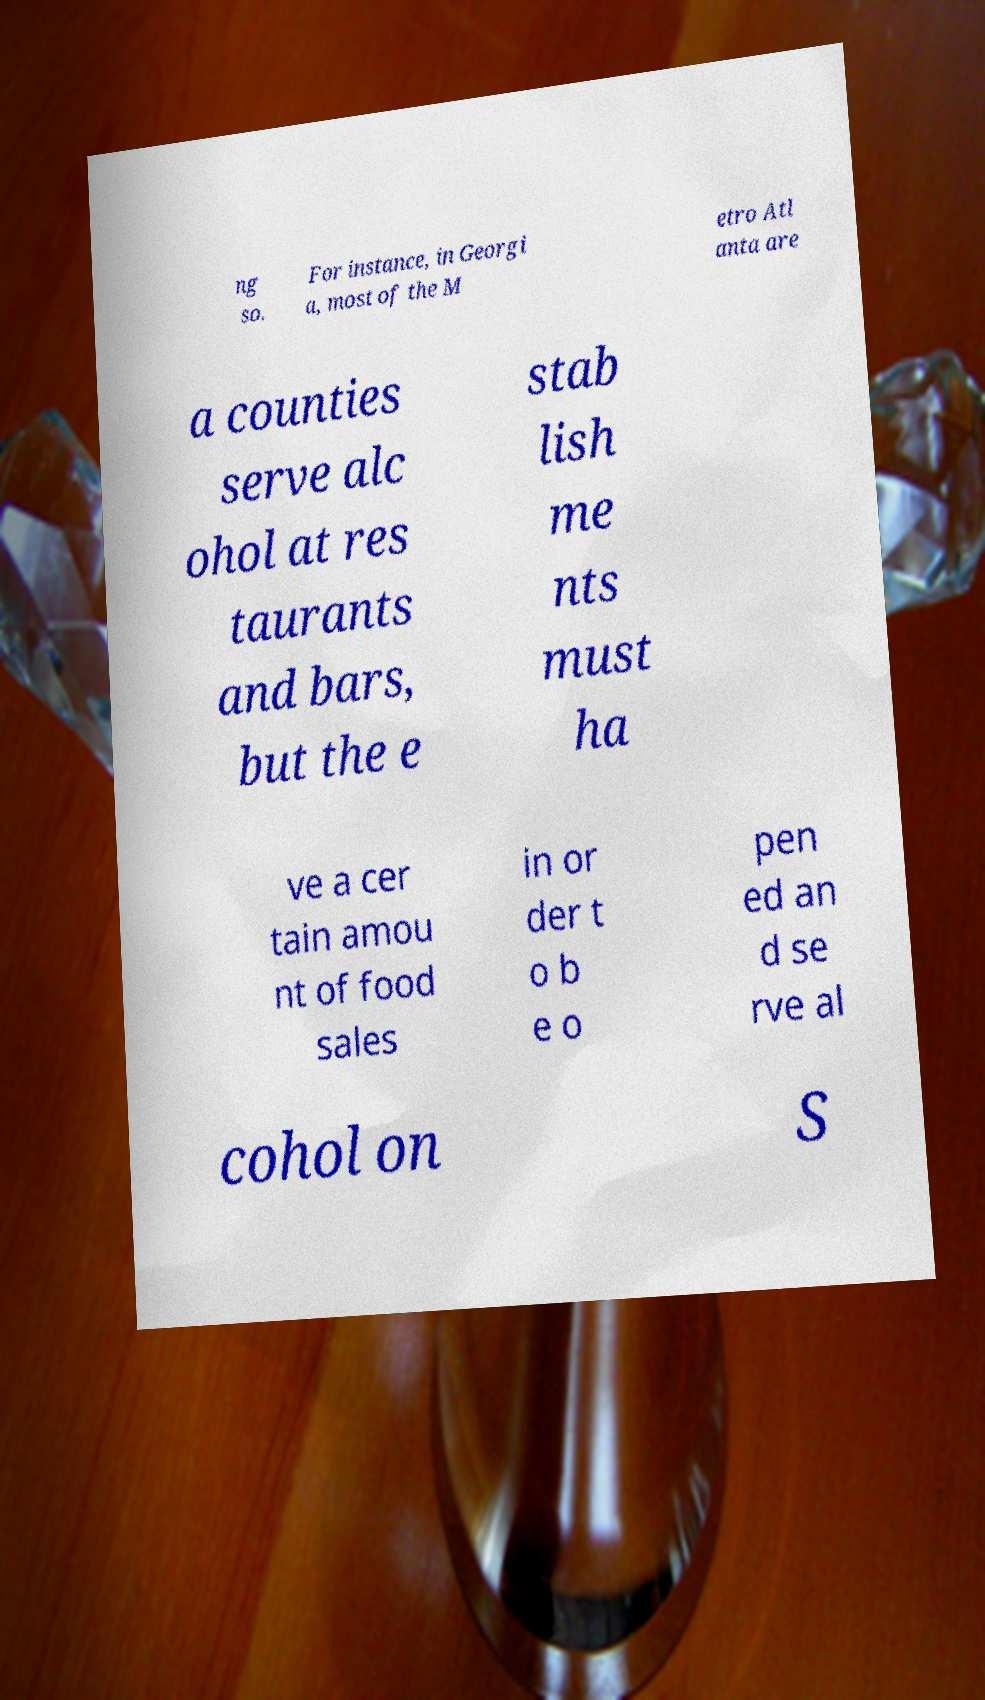Could you extract and type out the text from this image? ng so. For instance, in Georgi a, most of the M etro Atl anta are a counties serve alc ohol at res taurants and bars, but the e stab lish me nts must ha ve a cer tain amou nt of food sales in or der t o b e o pen ed an d se rve al cohol on S 